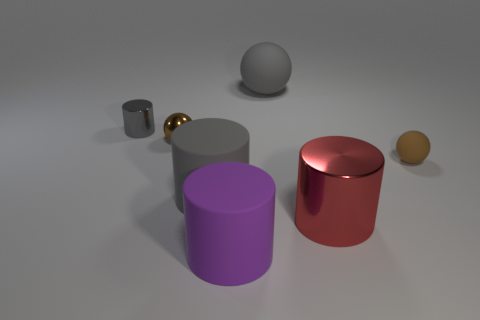What number of large yellow shiny blocks are there?
Ensure brevity in your answer.  0. Does the red metal object have the same shape as the large gray matte object right of the purple cylinder?
Ensure brevity in your answer.  No. There is a matte thing that is the same color as the large matte sphere; what size is it?
Make the answer very short. Large. How many objects are large gray rubber cylinders or big cylinders?
Offer a very short reply. 3. What is the shape of the brown thing right of the ball that is behind the gray shiny thing?
Provide a succinct answer. Sphere. There is a big gray object that is in front of the small gray cylinder; does it have the same shape as the large shiny object?
Ensure brevity in your answer.  Yes. There is a gray cylinder that is the same material as the large gray ball; what size is it?
Make the answer very short. Large. What number of things are either tiny spheres to the left of the large red cylinder or things left of the big red cylinder?
Your answer should be compact. 5. Are there an equal number of small gray cylinders left of the tiny cylinder and small brown objects that are to the right of the large purple matte thing?
Your answer should be very brief. No. The big cylinder on the right side of the big purple object is what color?
Provide a succinct answer. Red. 